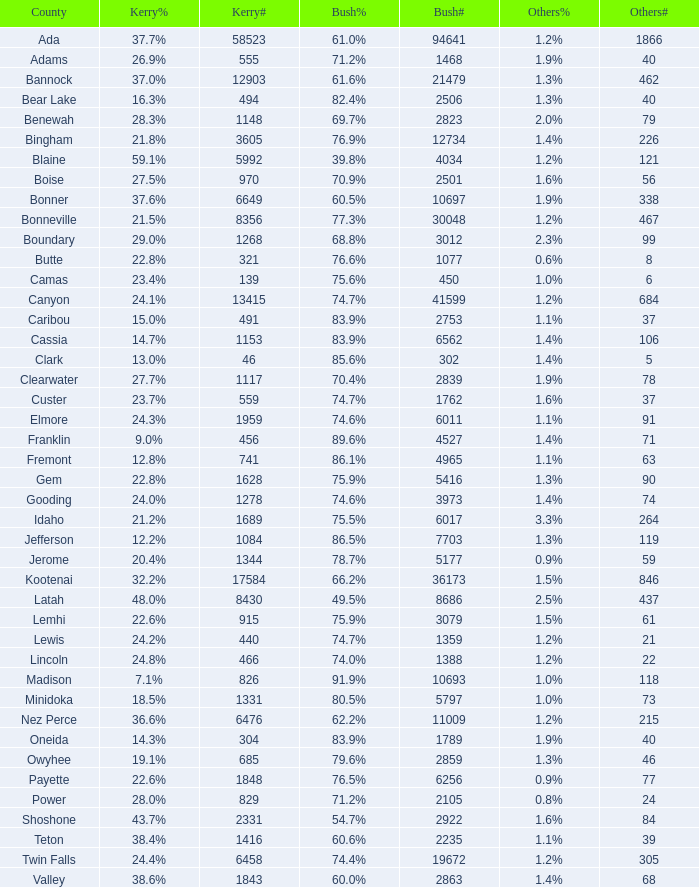How many people voted for Kerry in the county where 8 voted for others? 321.0. 